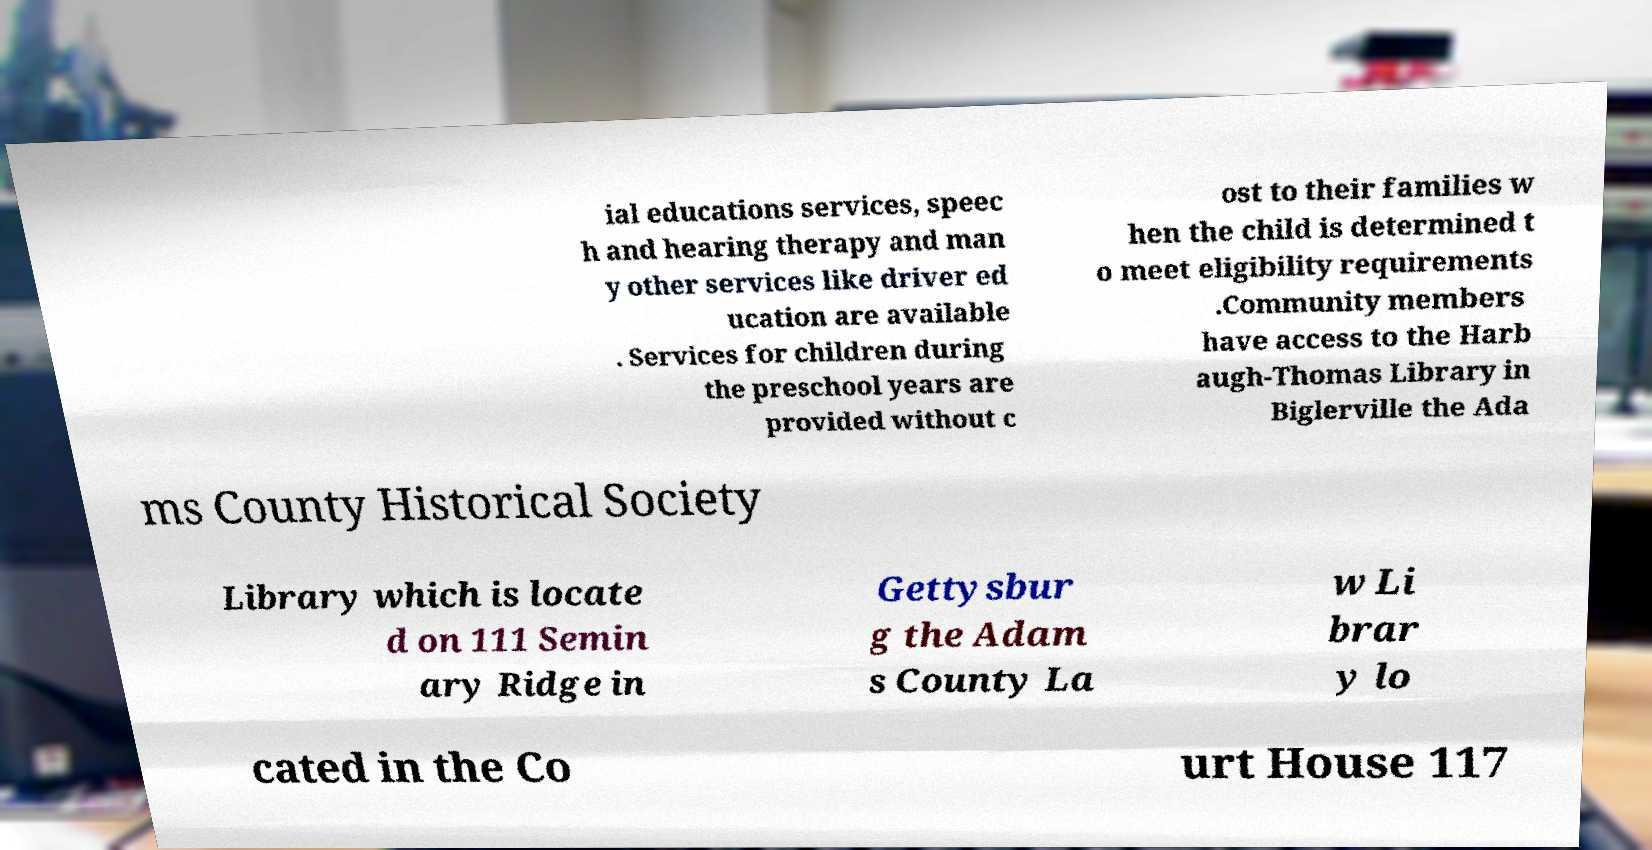There's text embedded in this image that I need extracted. Can you transcribe it verbatim? ial educations services, speec h and hearing therapy and man y other services like driver ed ucation are available . Services for children during the preschool years are provided without c ost to their families w hen the child is determined t o meet eligibility requirements .Community members have access to the Harb augh-Thomas Library in Biglerville the Ada ms County Historical Society Library which is locate d on 111 Semin ary Ridge in Gettysbur g the Adam s County La w Li brar y lo cated in the Co urt House 117 